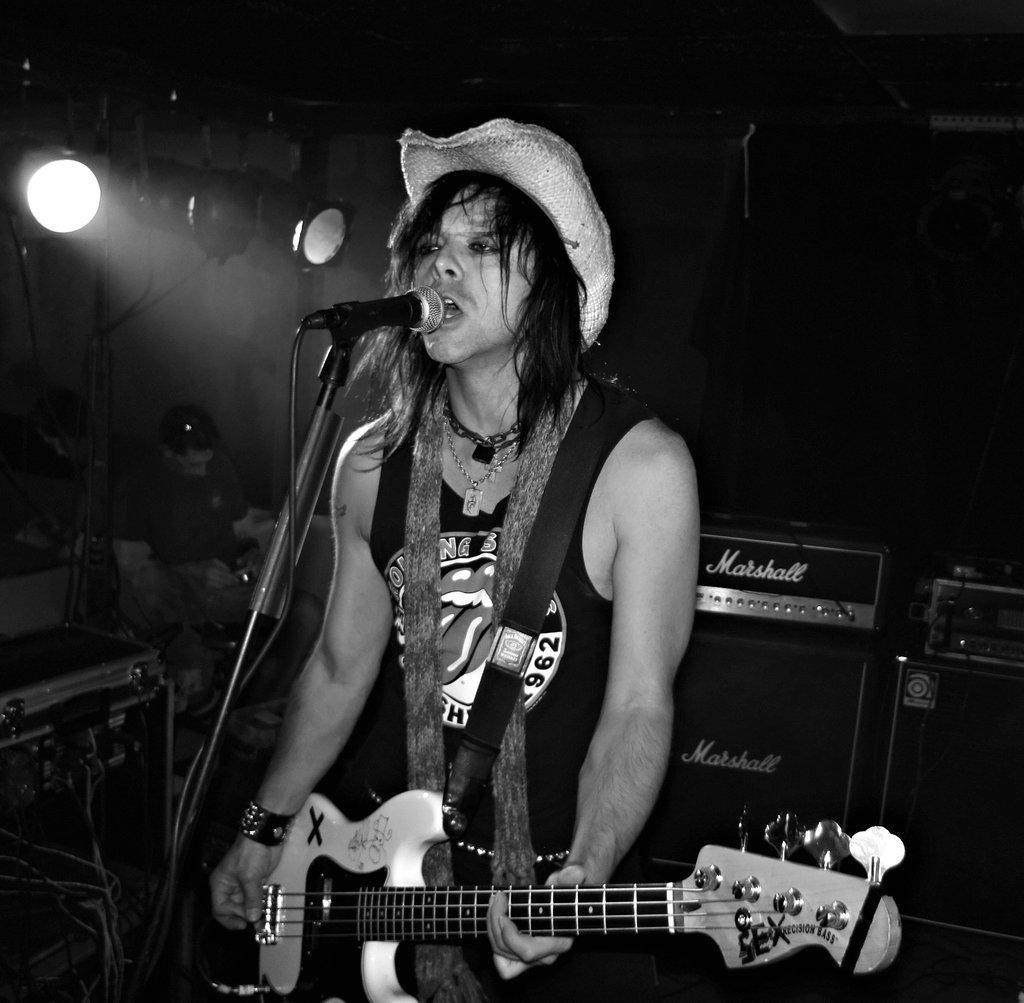Describe this image in one or two sentences. There is a person standing in front of a microphone holding a guitar in his hands. He's wearing a hat. In the background there are some people sitting and there is light here. 